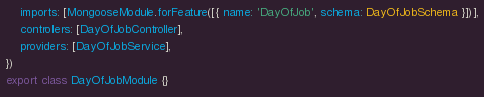Convert code to text. <code><loc_0><loc_0><loc_500><loc_500><_TypeScript_>    imports: [MongooseModule.forFeature([{ name: 'DayOfJob', schema: DayOfJobSchema }])],
    controllers: [DayOfJobController],
    providers: [DayOfJobService],
})
export class DayOfJobModule {}
</code> 